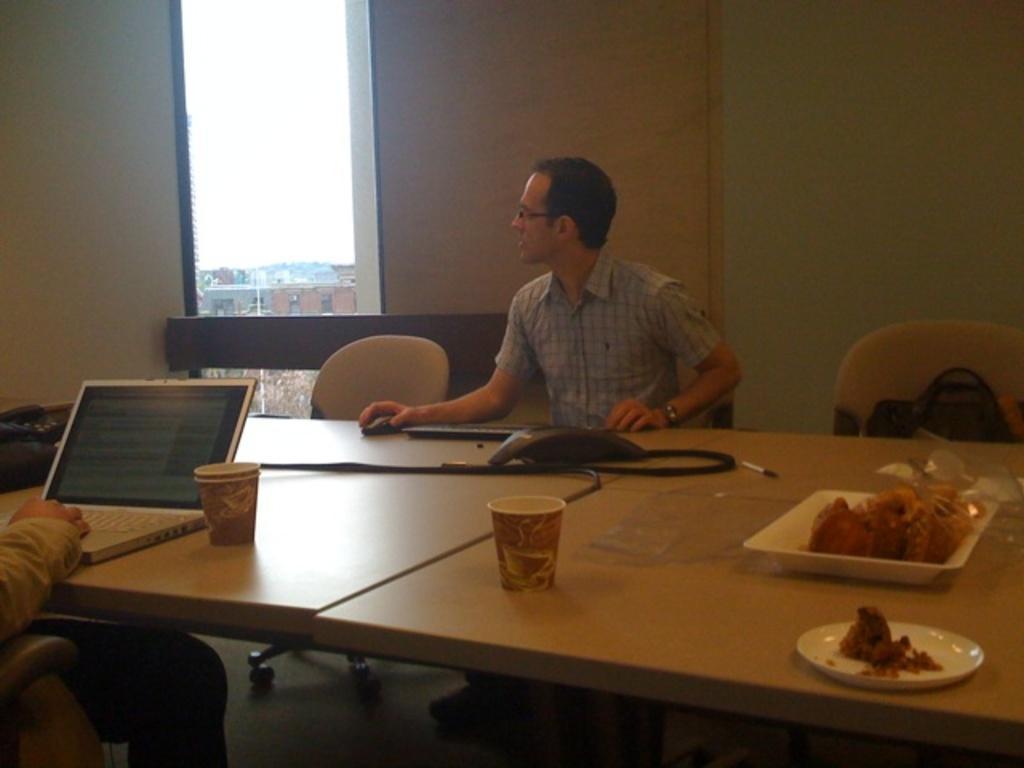Please provide a concise description of this image. In this image there are two person sitting on the chair. In front of the person there is table. There is a cup,plate,food on the table. At the back side we can see the window and the sky. 